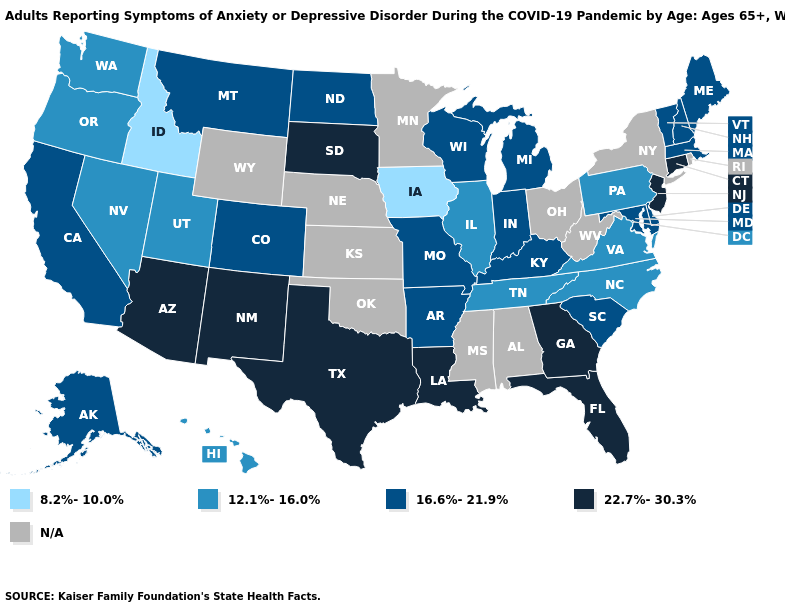What is the value of Delaware?
Short answer required. 16.6%-21.9%. What is the highest value in the Northeast ?
Be succinct. 22.7%-30.3%. What is the value of Hawaii?
Give a very brief answer. 12.1%-16.0%. Which states have the highest value in the USA?
Keep it brief. Arizona, Connecticut, Florida, Georgia, Louisiana, New Jersey, New Mexico, South Dakota, Texas. What is the highest value in states that border Iowa?
Give a very brief answer. 22.7%-30.3%. Name the states that have a value in the range 22.7%-30.3%?
Concise answer only. Arizona, Connecticut, Florida, Georgia, Louisiana, New Jersey, New Mexico, South Dakota, Texas. What is the value of Arkansas?
Quick response, please. 16.6%-21.9%. Name the states that have a value in the range N/A?
Quick response, please. Alabama, Kansas, Minnesota, Mississippi, Nebraska, New York, Ohio, Oklahoma, Rhode Island, West Virginia, Wyoming. Name the states that have a value in the range N/A?
Quick response, please. Alabama, Kansas, Minnesota, Mississippi, Nebraska, New York, Ohio, Oklahoma, Rhode Island, West Virginia, Wyoming. What is the value of Nebraska?
Write a very short answer. N/A. What is the value of Texas?
Answer briefly. 22.7%-30.3%. Among the states that border Maryland , which have the lowest value?
Answer briefly. Pennsylvania, Virginia. What is the value of Iowa?
Quick response, please. 8.2%-10.0%. 